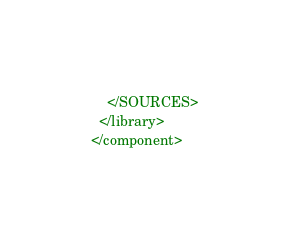<code> <loc_0><loc_0><loc_500><loc_500><_XML_>    </SOURCES>
  </library>
</component></code> 